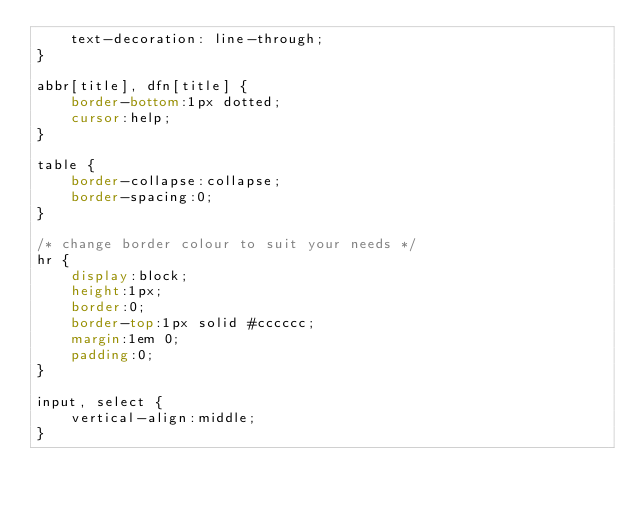Convert code to text. <code><loc_0><loc_0><loc_500><loc_500><_CSS_>    text-decoration: line-through;
}

abbr[title], dfn[title] {
    border-bottom:1px dotted;
    cursor:help;
}

table {
    border-collapse:collapse;
    border-spacing:0;
}

/* change border colour to suit your needs */
hr {
    display:block;
    height:1px;
    border:0;   
    border-top:1px solid #cccccc;
    margin:1em 0;
    padding:0;
}

input, select {
    vertical-align:middle;
}

</code> 